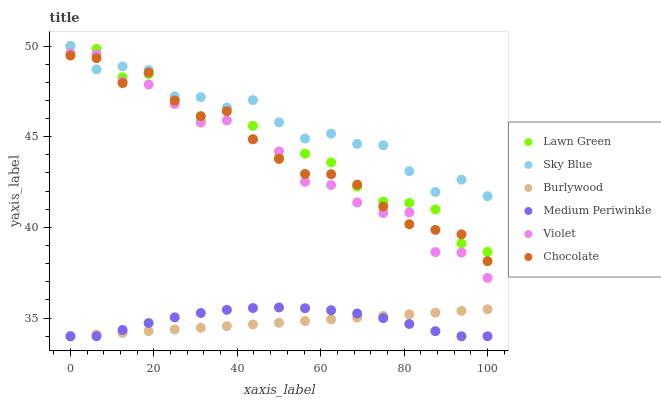Does Burlywood have the minimum area under the curve?
Answer yes or no. Yes. Does Sky Blue have the maximum area under the curve?
Answer yes or no. Yes. Does Medium Periwinkle have the minimum area under the curve?
Answer yes or no. No. Does Medium Periwinkle have the maximum area under the curve?
Answer yes or no. No. Is Burlywood the smoothest?
Answer yes or no. Yes. Is Lawn Green the roughest?
Answer yes or no. Yes. Is Medium Periwinkle the smoothest?
Answer yes or no. No. Is Medium Periwinkle the roughest?
Answer yes or no. No. Does Burlywood have the lowest value?
Answer yes or no. Yes. Does Chocolate have the lowest value?
Answer yes or no. No. Does Sky Blue have the highest value?
Answer yes or no. Yes. Does Medium Periwinkle have the highest value?
Answer yes or no. No. Is Medium Periwinkle less than Lawn Green?
Answer yes or no. Yes. Is Violet greater than Burlywood?
Answer yes or no. Yes. Does Sky Blue intersect Lawn Green?
Answer yes or no. Yes. Is Sky Blue less than Lawn Green?
Answer yes or no. No. Is Sky Blue greater than Lawn Green?
Answer yes or no. No. Does Medium Periwinkle intersect Lawn Green?
Answer yes or no. No. 